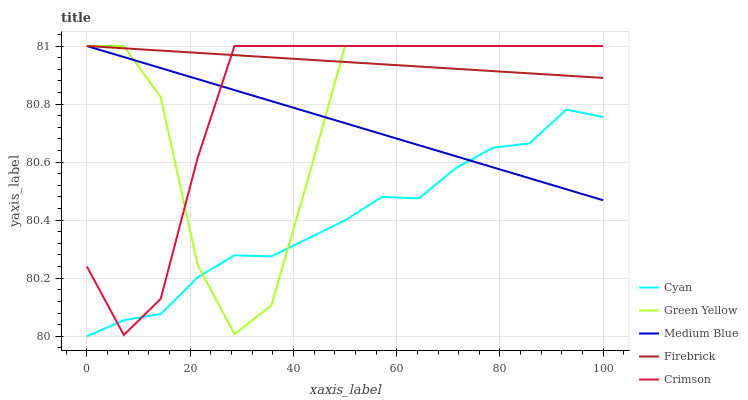Does Cyan have the minimum area under the curve?
Answer yes or no. Yes. Does Firebrick have the maximum area under the curve?
Answer yes or no. Yes. Does Firebrick have the minimum area under the curve?
Answer yes or no. No. Does Cyan have the maximum area under the curve?
Answer yes or no. No. Is Firebrick the smoothest?
Answer yes or no. Yes. Is Green Yellow the roughest?
Answer yes or no. Yes. Is Cyan the smoothest?
Answer yes or no. No. Is Cyan the roughest?
Answer yes or no. No. Does Cyan have the lowest value?
Answer yes or no. Yes. Does Firebrick have the lowest value?
Answer yes or no. No. Does Medium Blue have the highest value?
Answer yes or no. Yes. Does Cyan have the highest value?
Answer yes or no. No. Is Cyan less than Firebrick?
Answer yes or no. Yes. Is Firebrick greater than Cyan?
Answer yes or no. Yes. Does Crimson intersect Medium Blue?
Answer yes or no. Yes. Is Crimson less than Medium Blue?
Answer yes or no. No. Is Crimson greater than Medium Blue?
Answer yes or no. No. Does Cyan intersect Firebrick?
Answer yes or no. No. 